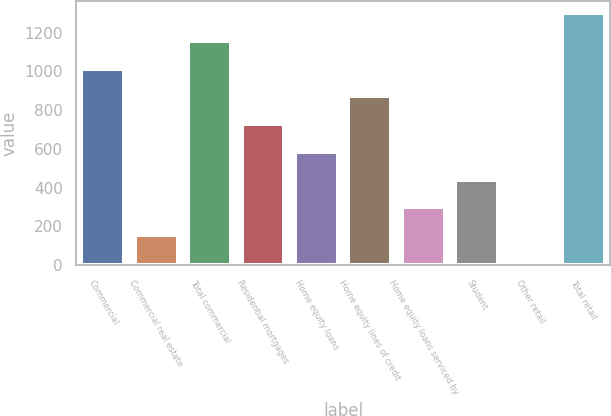<chart> <loc_0><loc_0><loc_500><loc_500><bar_chart><fcel>Commercial<fcel>Commercial real estate<fcel>Total commercial<fcel>Residential mortgages<fcel>Home equity loans<fcel>Home equity lines of credit<fcel>Home equity loans serviced by<fcel>Student<fcel>Other retail<fcel>Total retail<nl><fcel>1014<fcel>156<fcel>1157<fcel>728<fcel>585<fcel>871<fcel>299<fcel>442<fcel>13<fcel>1300<nl></chart> 